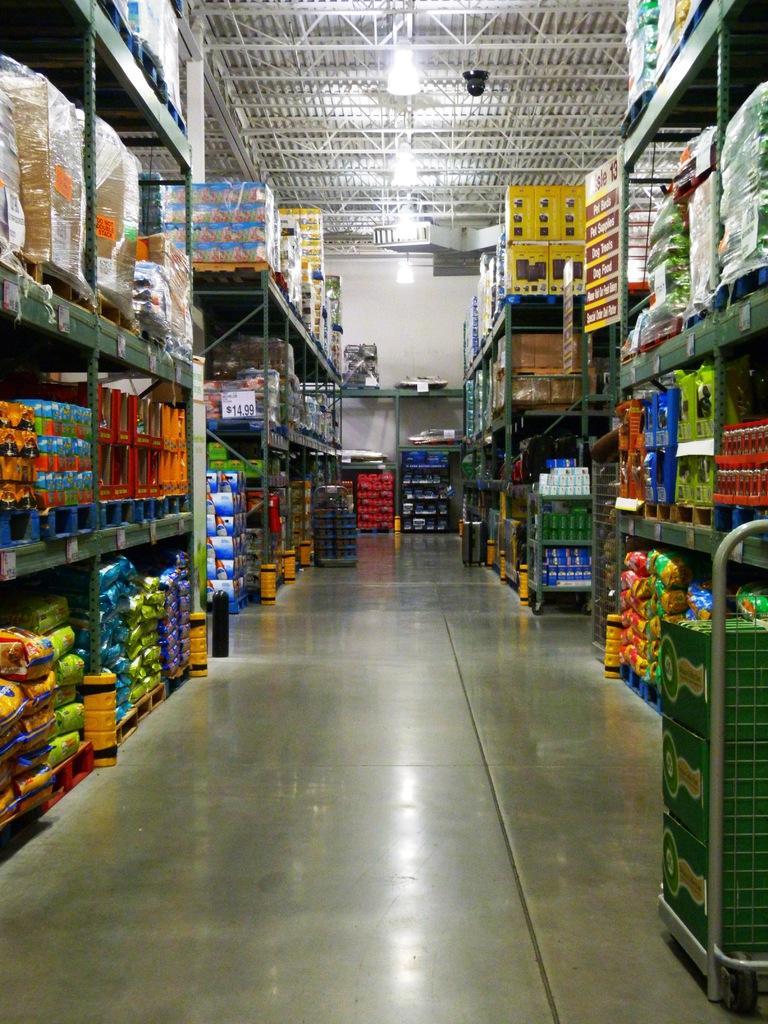In one or two sentences, can you explain what this image depicts? In this picture we can see shelves, at the left bottom there are some bags, we can see cardboard boxes on the left side, at the right bottom there is a trolley, we can see some things present on these shelves, there are some metal rods and lights at the top of the picture. 